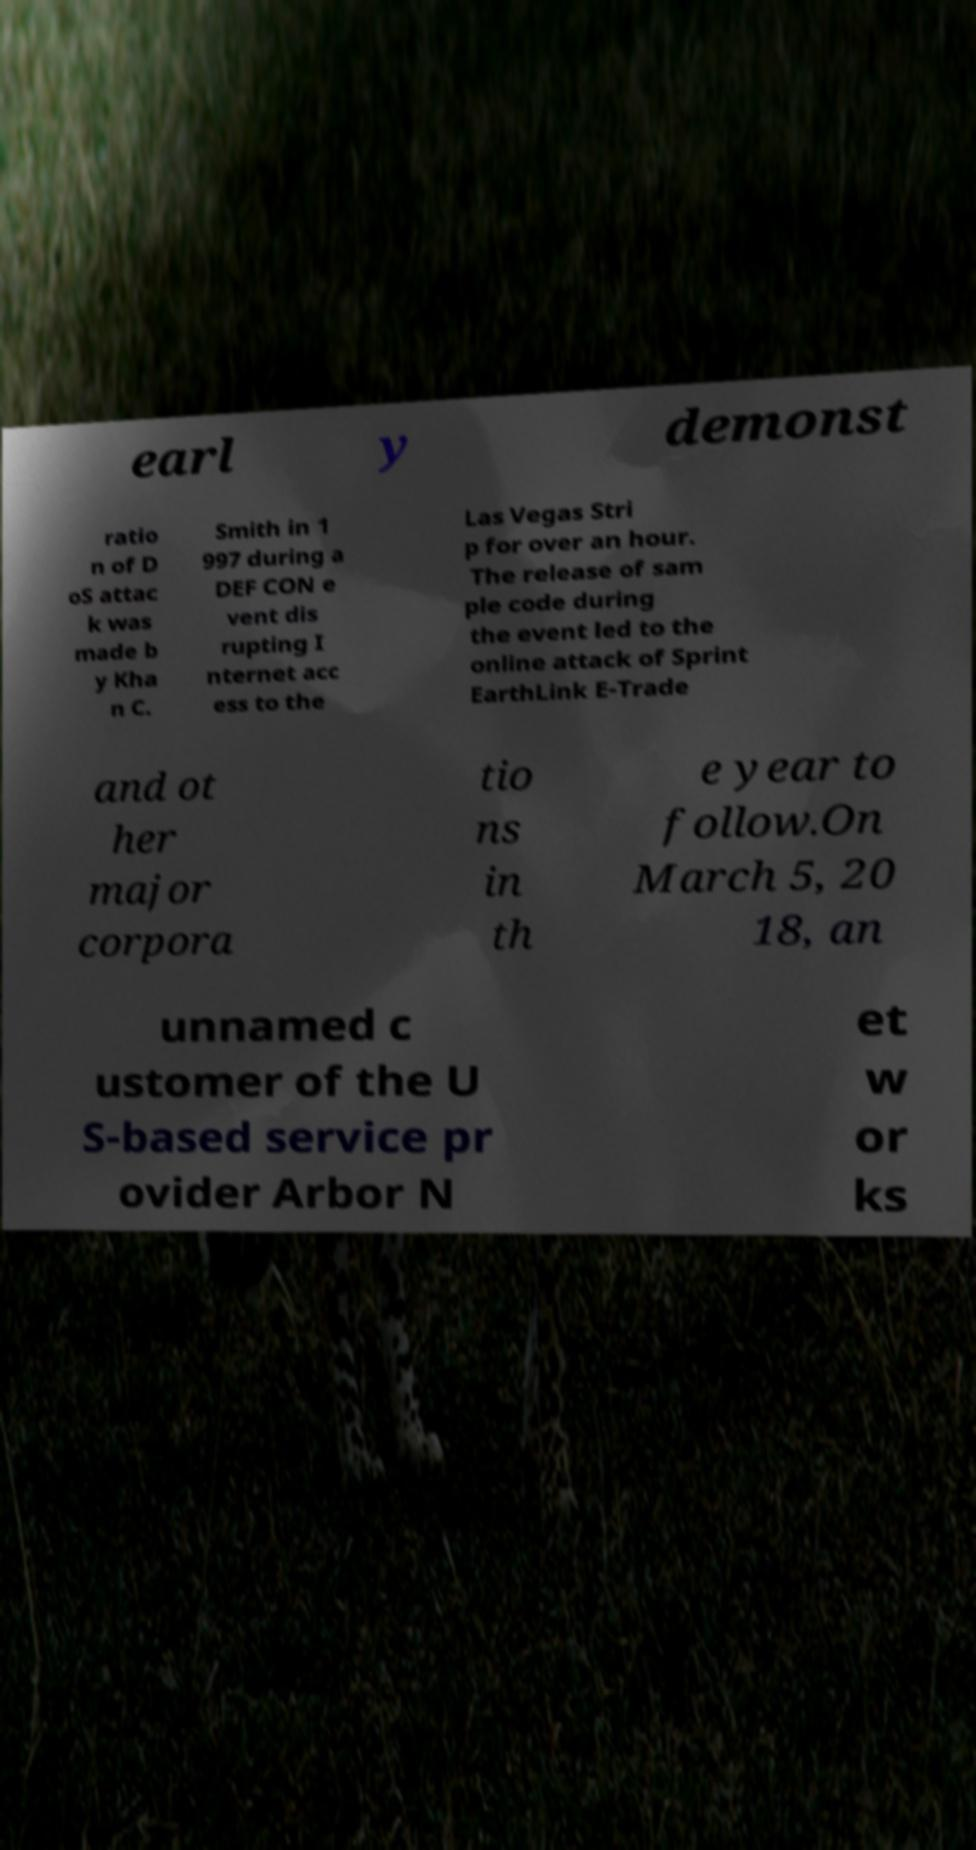For documentation purposes, I need the text within this image transcribed. Could you provide that? earl y demonst ratio n of D oS attac k was made b y Kha n C. Smith in 1 997 during a DEF CON e vent dis rupting I nternet acc ess to the Las Vegas Stri p for over an hour. The release of sam ple code during the event led to the online attack of Sprint EarthLink E-Trade and ot her major corpora tio ns in th e year to follow.On March 5, 20 18, an unnamed c ustomer of the U S-based service pr ovider Arbor N et w or ks 